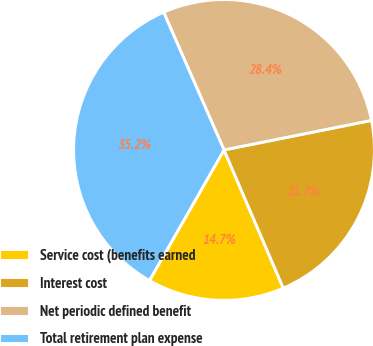Convert chart to OTSL. <chart><loc_0><loc_0><loc_500><loc_500><pie_chart><fcel>Service cost (benefits earned<fcel>Interest cost<fcel>Net periodic defined benefit<fcel>Total retirement plan expense<nl><fcel>14.71%<fcel>21.7%<fcel>28.43%<fcel>35.16%<nl></chart> 